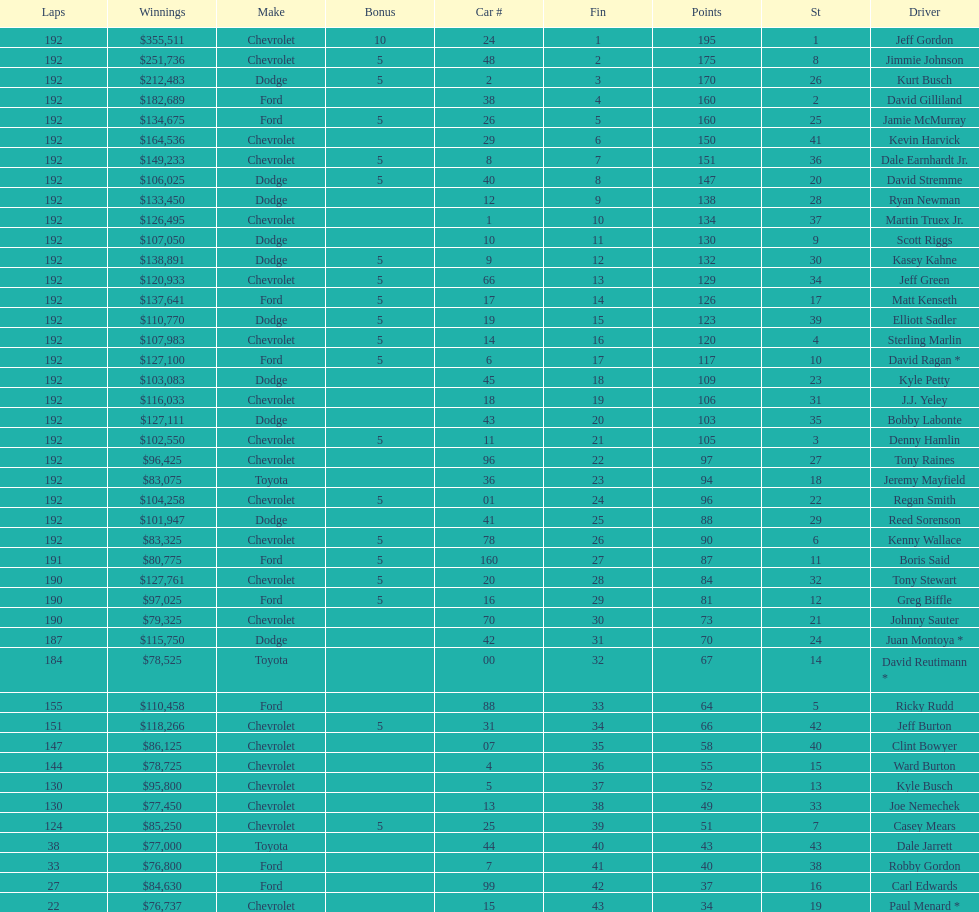How many drivers earned no bonus for this race? 23. 